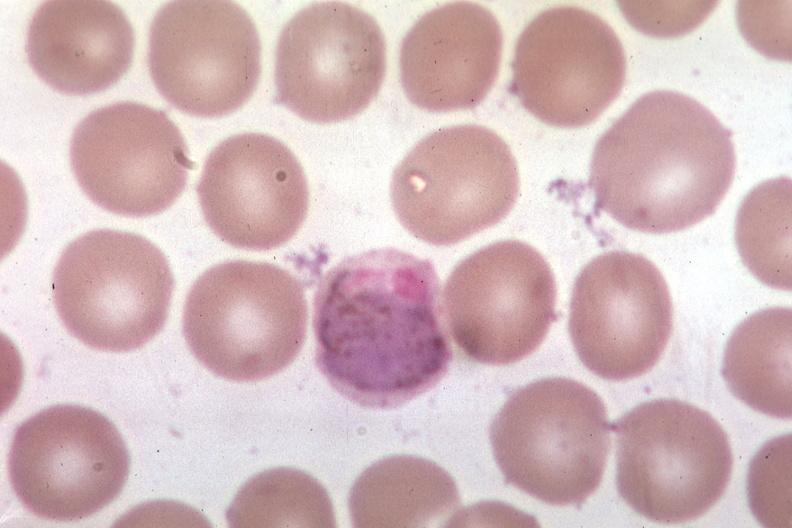does this image show oil wrights?
Answer the question using a single word or phrase. Yes 